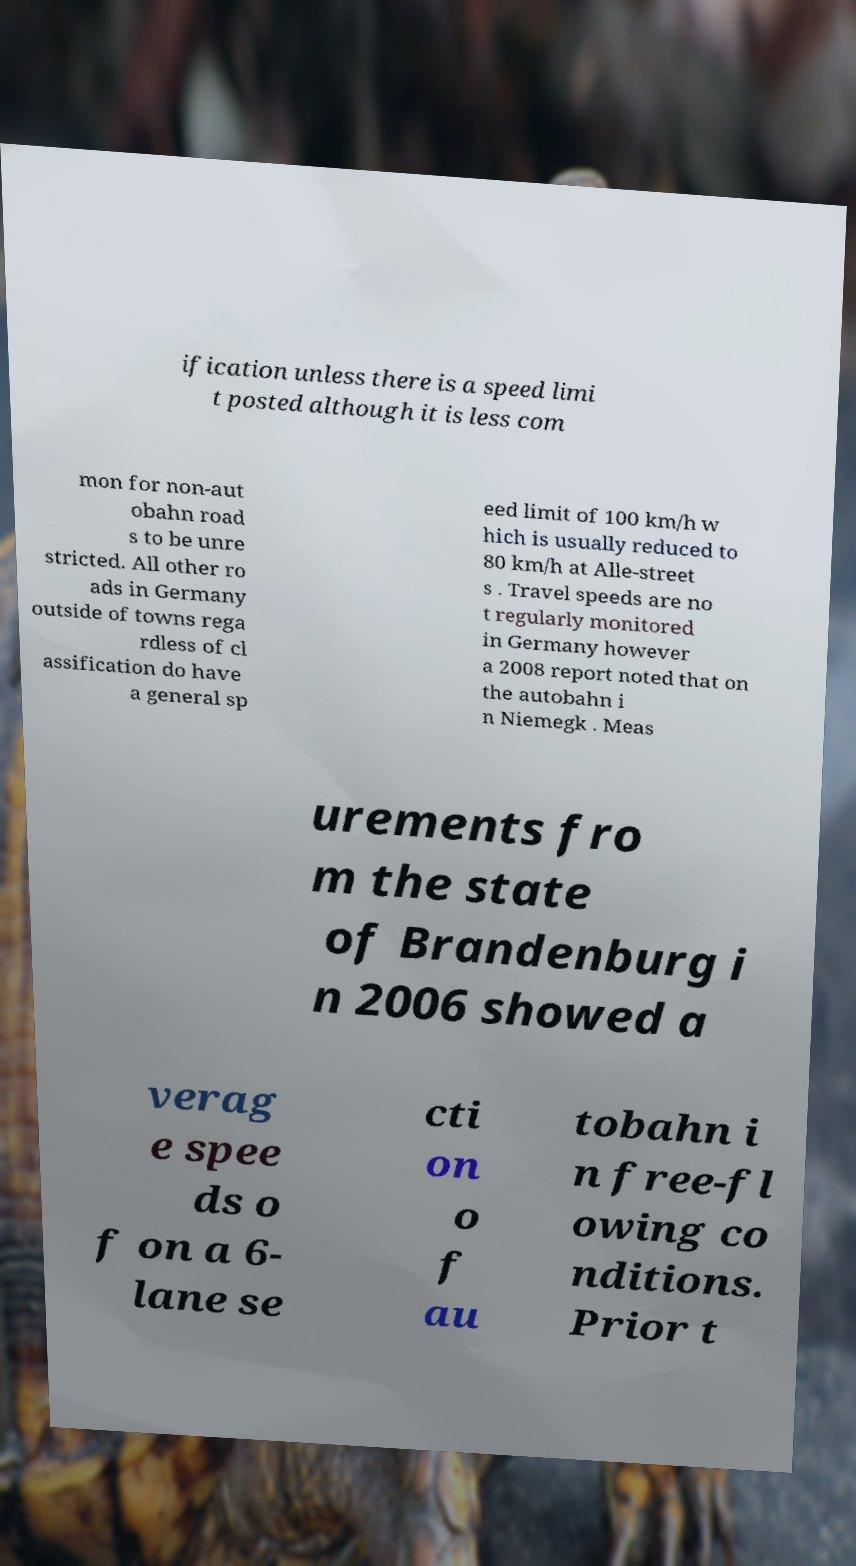What messages or text are displayed in this image? I need them in a readable, typed format. ification unless there is a speed limi t posted although it is less com mon for non-aut obahn road s to be unre stricted. All other ro ads in Germany outside of towns rega rdless of cl assification do have a general sp eed limit of 100 km/h w hich is usually reduced to 80 km/h at Alle-street s . Travel speeds are no t regularly monitored in Germany however a 2008 report noted that on the autobahn i n Niemegk . Meas urements fro m the state of Brandenburg i n 2006 showed a verag e spee ds o f on a 6- lane se cti on o f au tobahn i n free-fl owing co nditions. Prior t 